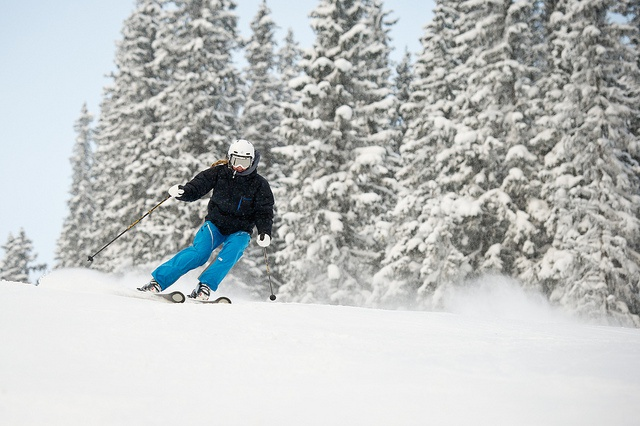Describe the objects in this image and their specific colors. I can see people in lightblue, black, teal, and lightgray tones and skis in lightblue, lightgray, darkgray, gray, and black tones in this image. 